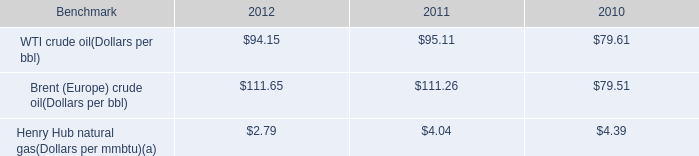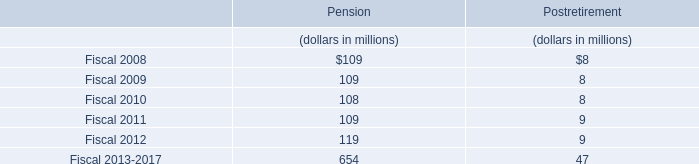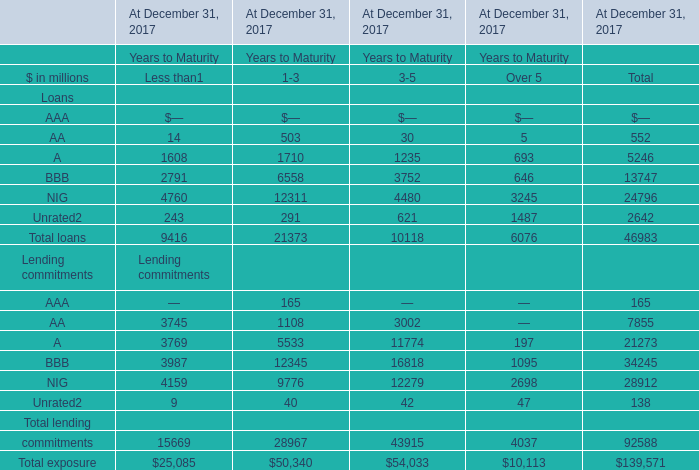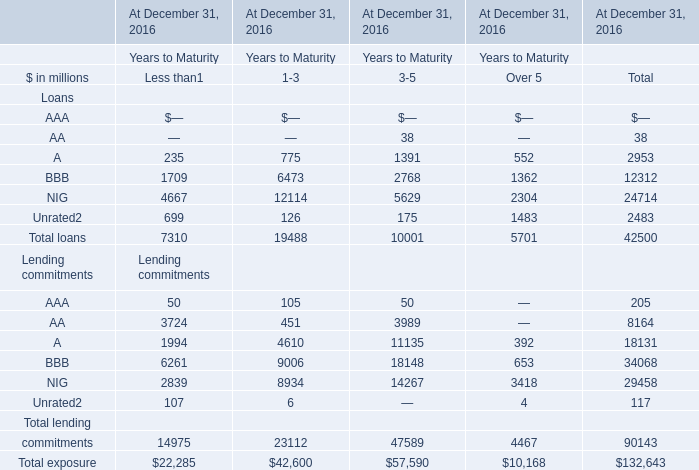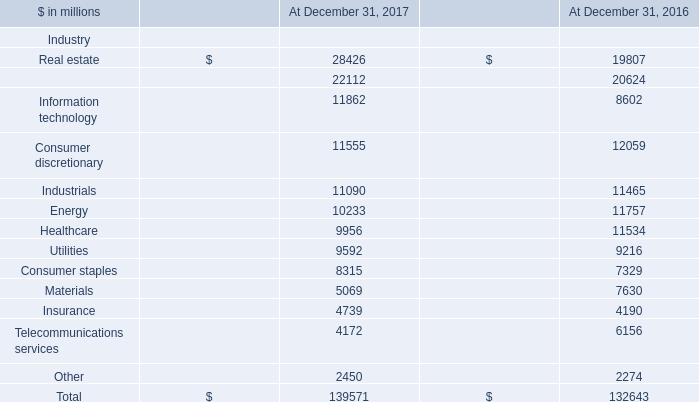by what percentage did the average price of brent ( europe ) crude oil increase from 2010 to 2012? 
Computations: ((111.65 - 79.51) / 79.51)
Answer: 0.40423. 